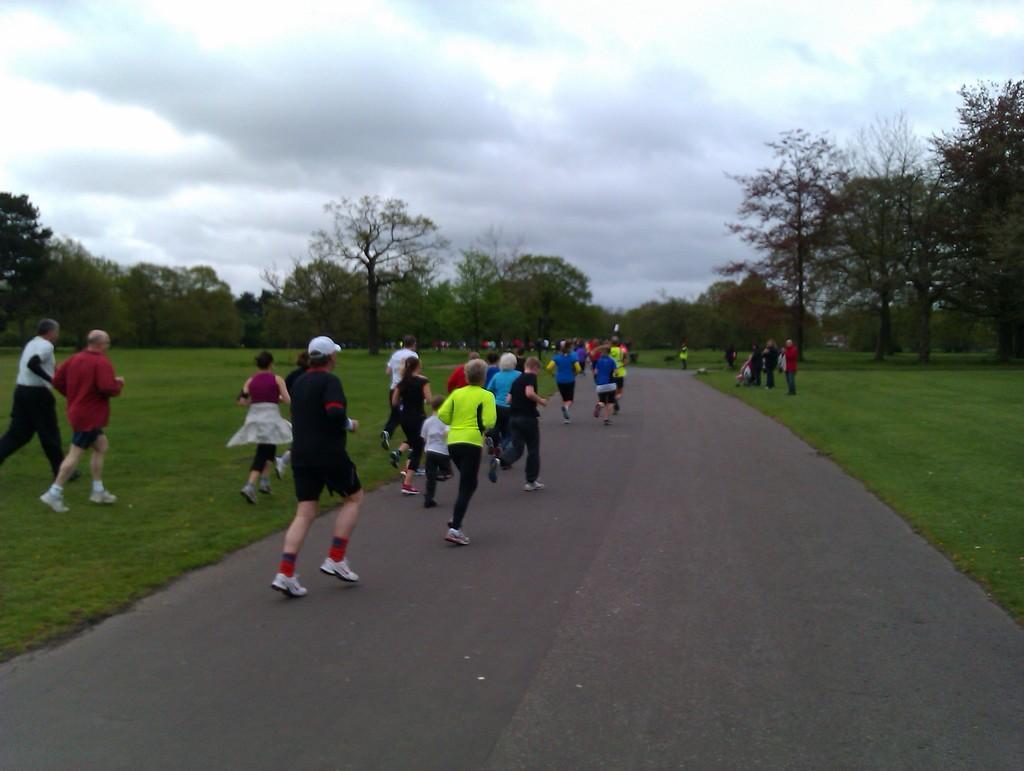Could you give a brief overview of what you see in this image? In this picture we can see so many people are running on the road and beside the road, beside the road we can see full of grass and trees. 